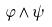Convert formula to latex. <formula><loc_0><loc_0><loc_500><loc_500>\varphi \wedge \psi</formula> 